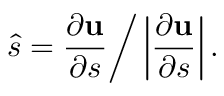Convert formula to latex. <formula><loc_0><loc_0><loc_500><loc_500>\hat { s } = \frac { \partial { u } } { \partial s } \Big / \left | \frac { \partial { u } } { \partial s } \right | .</formula> 